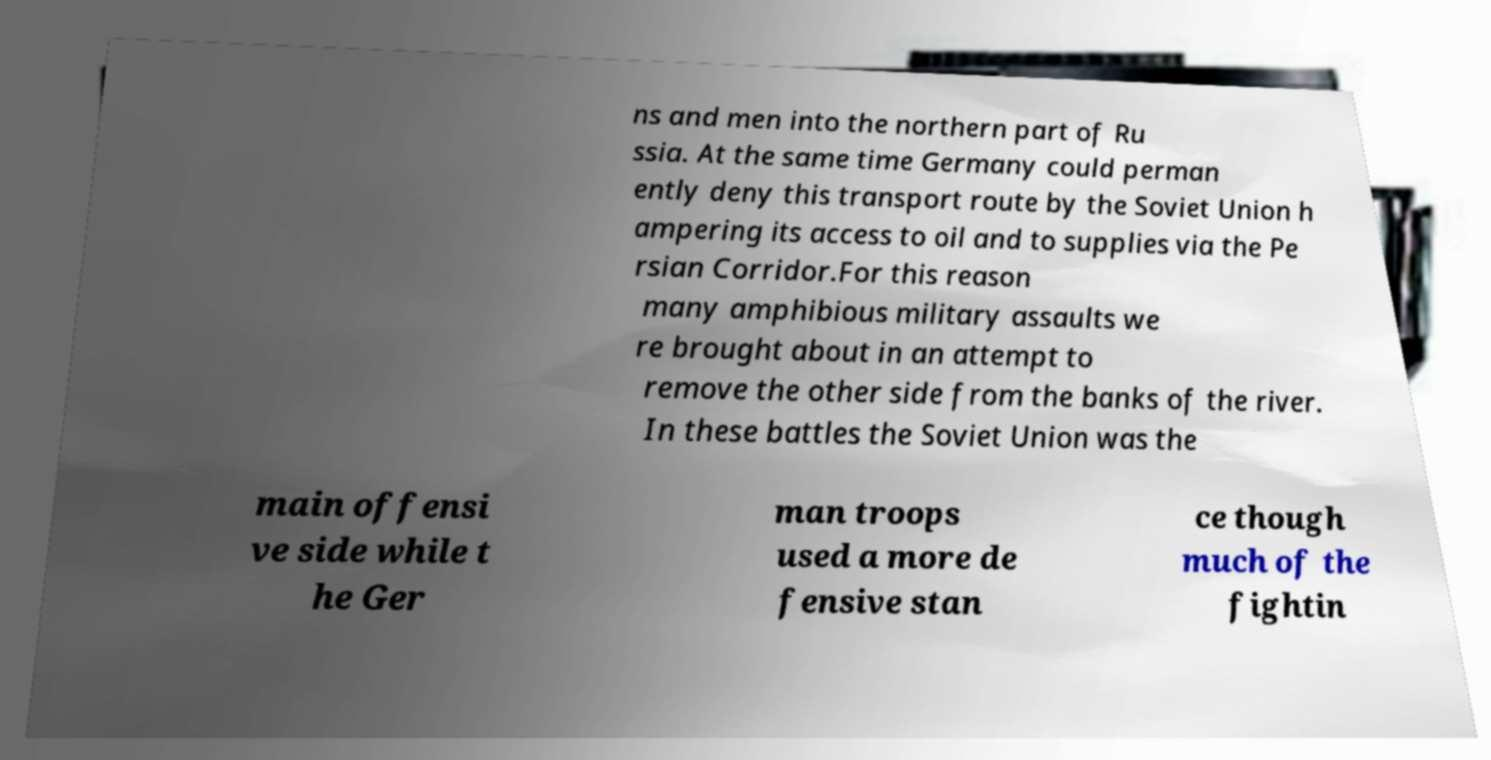Please read and relay the text visible in this image. What does it say? ns and men into the northern part of Ru ssia. At the same time Germany could perman ently deny this transport route by the Soviet Union h ampering its access to oil and to supplies via the Pe rsian Corridor.For this reason many amphibious military assaults we re brought about in an attempt to remove the other side from the banks of the river. In these battles the Soviet Union was the main offensi ve side while t he Ger man troops used a more de fensive stan ce though much of the fightin 